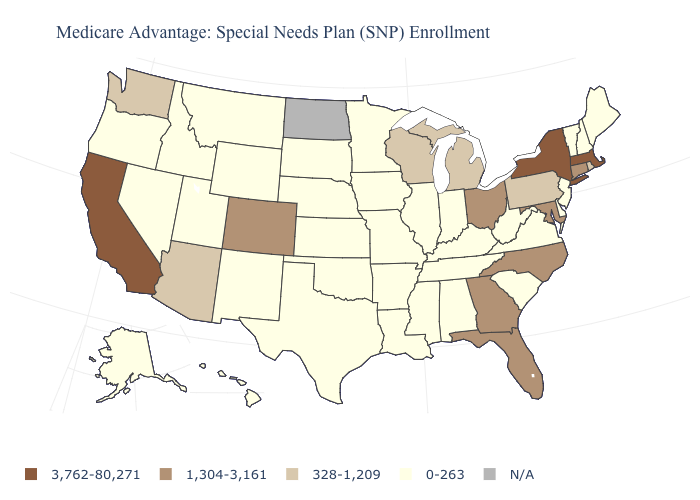Name the states that have a value in the range N/A?
Give a very brief answer. North Dakota. Which states have the lowest value in the Northeast?
Short answer required. Maine, New Hampshire, New Jersey, Vermont. What is the value of Connecticut?
Be succinct. 1,304-3,161. Name the states that have a value in the range 328-1,209?
Keep it brief. Arizona, Michigan, Pennsylvania, Rhode Island, Washington, Wisconsin. Name the states that have a value in the range 328-1,209?
Write a very short answer. Arizona, Michigan, Pennsylvania, Rhode Island, Washington, Wisconsin. Which states have the highest value in the USA?
Short answer required. California, Massachusetts, New York. Name the states that have a value in the range 328-1,209?
Concise answer only. Arizona, Michigan, Pennsylvania, Rhode Island, Washington, Wisconsin. Does the map have missing data?
Keep it brief. Yes. What is the lowest value in the USA?
Short answer required. 0-263. What is the lowest value in the West?
Keep it brief. 0-263. Name the states that have a value in the range 0-263?
Quick response, please. Alaska, Alabama, Arkansas, Delaware, Hawaii, Iowa, Idaho, Illinois, Indiana, Kansas, Kentucky, Louisiana, Maine, Minnesota, Missouri, Mississippi, Montana, Nebraska, New Hampshire, New Jersey, New Mexico, Nevada, Oklahoma, Oregon, South Carolina, South Dakota, Tennessee, Texas, Utah, Virginia, Vermont, West Virginia, Wyoming. What is the highest value in states that border Montana?
Keep it brief. 0-263. Which states have the highest value in the USA?
Short answer required. California, Massachusetts, New York. 